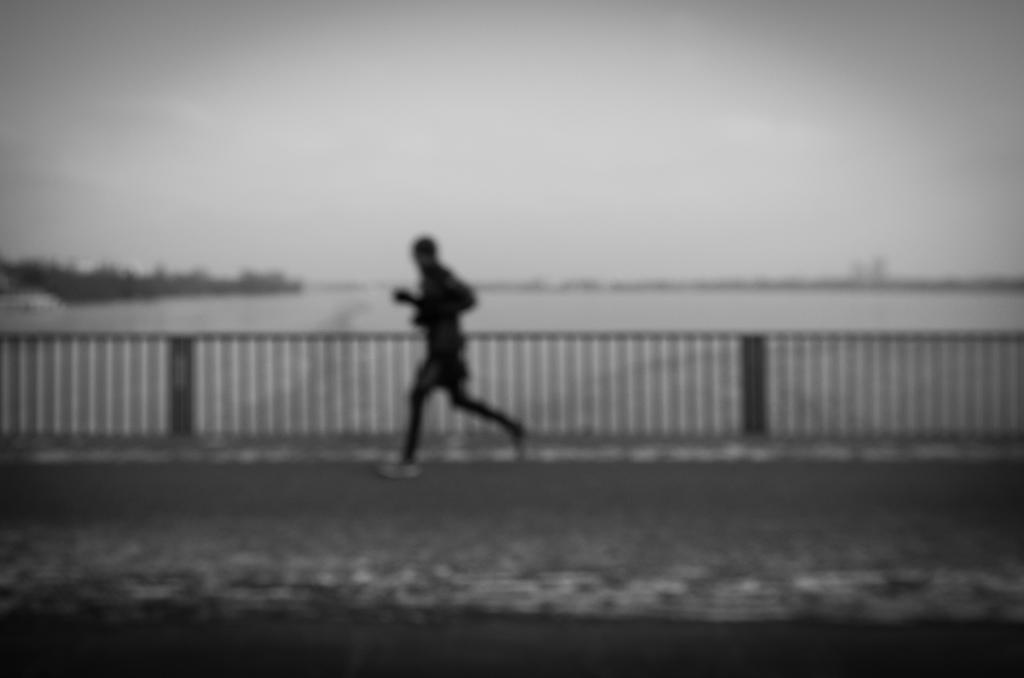Where was the picture taken? The picture was taken outside. What is the main subject of the image? There is a person in the center of the image, who appears to be running on the ground. What can be seen in the background of the image? The sky is visible in the background of the image, along with other unspecified items. What is the purpose of the fence in the image? The purpose of the fence in the image is not specified, but it could be for boundary or safety reasons. What news story is the person in the image reacting to? There is no indication of a news story or any reaction in the image; it simply shows a person running with a fence in the background. 